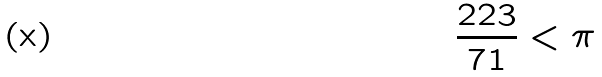Convert formula to latex. <formula><loc_0><loc_0><loc_500><loc_500>\frac { 2 2 3 } { 7 1 } < \pi</formula> 